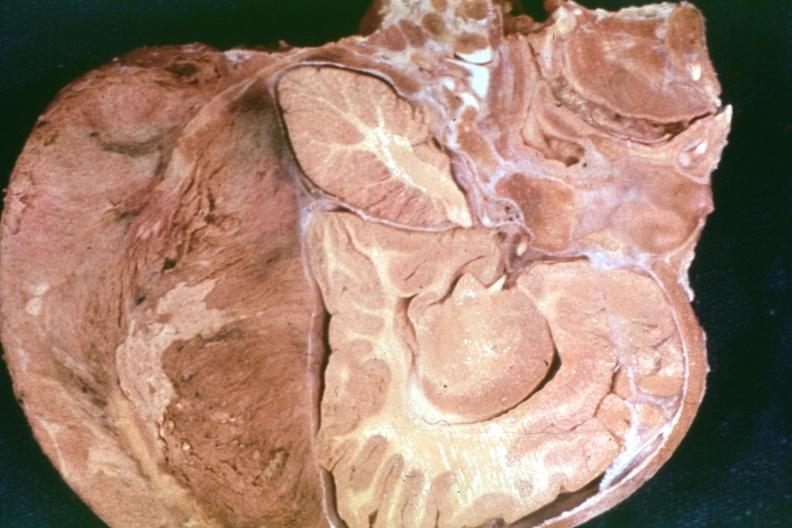what is present?
Answer the question using a single word or phrase. Bone 